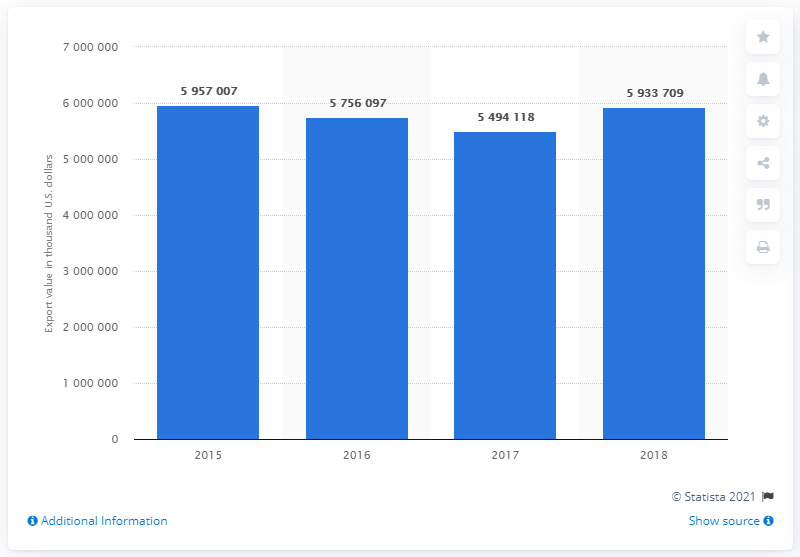Give some essential details in this illustration. Exports of German automotive parts declined from 6 billion U.S. dollars in 2015 to 5.49 billion U.S. dollars in 2017. 